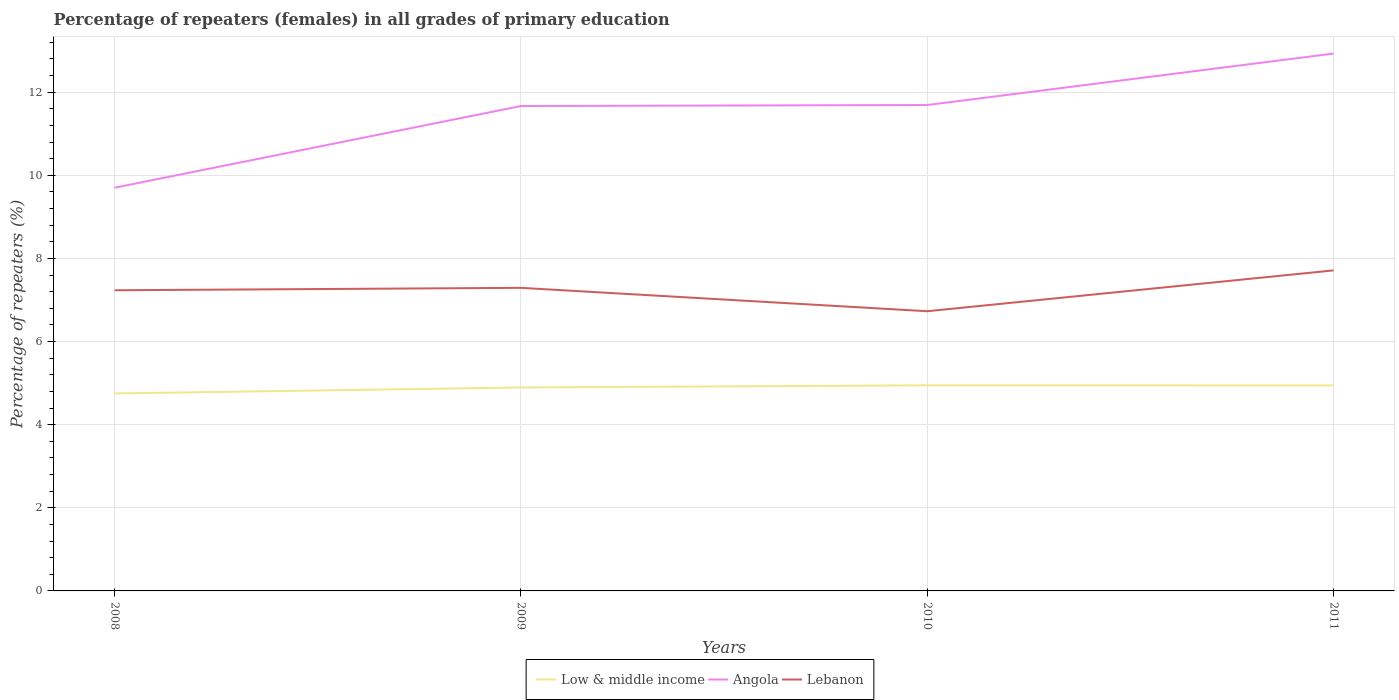Does the line corresponding to Low & middle income intersect with the line corresponding to Lebanon?
Ensure brevity in your answer.  No. Across all years, what is the maximum percentage of repeaters (females) in Angola?
Ensure brevity in your answer.  9.7. What is the total percentage of repeaters (females) in Low & middle income in the graph?
Offer a terse response. -0.2. What is the difference between the highest and the second highest percentage of repeaters (females) in Lebanon?
Your response must be concise. 0.98. Is the percentage of repeaters (females) in Low & middle income strictly greater than the percentage of repeaters (females) in Angola over the years?
Offer a terse response. Yes. How many lines are there?
Ensure brevity in your answer.  3. Does the graph contain any zero values?
Offer a very short reply. No. Does the graph contain grids?
Give a very brief answer. Yes. Where does the legend appear in the graph?
Offer a terse response. Bottom center. What is the title of the graph?
Make the answer very short. Percentage of repeaters (females) in all grades of primary education. Does "Russian Federation" appear as one of the legend labels in the graph?
Give a very brief answer. No. What is the label or title of the X-axis?
Provide a short and direct response. Years. What is the label or title of the Y-axis?
Give a very brief answer. Percentage of repeaters (%). What is the Percentage of repeaters (%) of Low & middle income in 2008?
Give a very brief answer. 4.75. What is the Percentage of repeaters (%) in Angola in 2008?
Offer a terse response. 9.7. What is the Percentage of repeaters (%) in Lebanon in 2008?
Provide a succinct answer. 7.23. What is the Percentage of repeaters (%) in Low & middle income in 2009?
Make the answer very short. 4.89. What is the Percentage of repeaters (%) in Angola in 2009?
Give a very brief answer. 11.67. What is the Percentage of repeaters (%) of Lebanon in 2009?
Your answer should be very brief. 7.29. What is the Percentage of repeaters (%) in Low & middle income in 2010?
Offer a very short reply. 4.95. What is the Percentage of repeaters (%) of Angola in 2010?
Ensure brevity in your answer.  11.69. What is the Percentage of repeaters (%) in Lebanon in 2010?
Give a very brief answer. 6.73. What is the Percentage of repeaters (%) of Low & middle income in 2011?
Your answer should be very brief. 4.94. What is the Percentage of repeaters (%) of Angola in 2011?
Give a very brief answer. 12.93. What is the Percentage of repeaters (%) in Lebanon in 2011?
Ensure brevity in your answer.  7.71. Across all years, what is the maximum Percentage of repeaters (%) of Low & middle income?
Your response must be concise. 4.95. Across all years, what is the maximum Percentage of repeaters (%) of Angola?
Your answer should be compact. 12.93. Across all years, what is the maximum Percentage of repeaters (%) of Lebanon?
Your answer should be compact. 7.71. Across all years, what is the minimum Percentage of repeaters (%) of Low & middle income?
Give a very brief answer. 4.75. Across all years, what is the minimum Percentage of repeaters (%) in Angola?
Offer a very short reply. 9.7. Across all years, what is the minimum Percentage of repeaters (%) of Lebanon?
Make the answer very short. 6.73. What is the total Percentage of repeaters (%) of Low & middle income in the graph?
Provide a short and direct response. 19.54. What is the total Percentage of repeaters (%) of Angola in the graph?
Ensure brevity in your answer.  45.99. What is the total Percentage of repeaters (%) of Lebanon in the graph?
Your answer should be compact. 28.97. What is the difference between the Percentage of repeaters (%) of Low & middle income in 2008 and that in 2009?
Your answer should be compact. -0.14. What is the difference between the Percentage of repeaters (%) in Angola in 2008 and that in 2009?
Provide a succinct answer. -1.97. What is the difference between the Percentage of repeaters (%) in Lebanon in 2008 and that in 2009?
Your answer should be compact. -0.06. What is the difference between the Percentage of repeaters (%) of Low & middle income in 2008 and that in 2010?
Your response must be concise. -0.2. What is the difference between the Percentage of repeaters (%) of Angola in 2008 and that in 2010?
Your answer should be compact. -1.99. What is the difference between the Percentage of repeaters (%) of Lebanon in 2008 and that in 2010?
Your answer should be very brief. 0.5. What is the difference between the Percentage of repeaters (%) in Low & middle income in 2008 and that in 2011?
Offer a terse response. -0.19. What is the difference between the Percentage of repeaters (%) in Angola in 2008 and that in 2011?
Offer a very short reply. -3.23. What is the difference between the Percentage of repeaters (%) of Lebanon in 2008 and that in 2011?
Offer a terse response. -0.48. What is the difference between the Percentage of repeaters (%) in Low & middle income in 2009 and that in 2010?
Ensure brevity in your answer.  -0.05. What is the difference between the Percentage of repeaters (%) in Angola in 2009 and that in 2010?
Provide a short and direct response. -0.02. What is the difference between the Percentage of repeaters (%) in Lebanon in 2009 and that in 2010?
Your response must be concise. 0.56. What is the difference between the Percentage of repeaters (%) of Angola in 2009 and that in 2011?
Provide a succinct answer. -1.26. What is the difference between the Percentage of repeaters (%) in Lebanon in 2009 and that in 2011?
Make the answer very short. -0.42. What is the difference between the Percentage of repeaters (%) of Low & middle income in 2010 and that in 2011?
Give a very brief answer. 0. What is the difference between the Percentage of repeaters (%) of Angola in 2010 and that in 2011?
Ensure brevity in your answer.  -1.24. What is the difference between the Percentage of repeaters (%) in Lebanon in 2010 and that in 2011?
Give a very brief answer. -0.98. What is the difference between the Percentage of repeaters (%) of Low & middle income in 2008 and the Percentage of repeaters (%) of Angola in 2009?
Keep it short and to the point. -6.92. What is the difference between the Percentage of repeaters (%) in Low & middle income in 2008 and the Percentage of repeaters (%) in Lebanon in 2009?
Offer a very short reply. -2.54. What is the difference between the Percentage of repeaters (%) in Angola in 2008 and the Percentage of repeaters (%) in Lebanon in 2009?
Offer a very short reply. 2.41. What is the difference between the Percentage of repeaters (%) in Low & middle income in 2008 and the Percentage of repeaters (%) in Angola in 2010?
Make the answer very short. -6.94. What is the difference between the Percentage of repeaters (%) in Low & middle income in 2008 and the Percentage of repeaters (%) in Lebanon in 2010?
Ensure brevity in your answer.  -1.98. What is the difference between the Percentage of repeaters (%) of Angola in 2008 and the Percentage of repeaters (%) of Lebanon in 2010?
Offer a very short reply. 2.97. What is the difference between the Percentage of repeaters (%) of Low & middle income in 2008 and the Percentage of repeaters (%) of Angola in 2011?
Provide a short and direct response. -8.18. What is the difference between the Percentage of repeaters (%) in Low & middle income in 2008 and the Percentage of repeaters (%) in Lebanon in 2011?
Your response must be concise. -2.96. What is the difference between the Percentage of repeaters (%) of Angola in 2008 and the Percentage of repeaters (%) of Lebanon in 2011?
Keep it short and to the point. 1.99. What is the difference between the Percentage of repeaters (%) of Low & middle income in 2009 and the Percentage of repeaters (%) of Angola in 2010?
Ensure brevity in your answer.  -6.8. What is the difference between the Percentage of repeaters (%) in Low & middle income in 2009 and the Percentage of repeaters (%) in Lebanon in 2010?
Provide a succinct answer. -1.83. What is the difference between the Percentage of repeaters (%) in Angola in 2009 and the Percentage of repeaters (%) in Lebanon in 2010?
Offer a very short reply. 4.94. What is the difference between the Percentage of repeaters (%) of Low & middle income in 2009 and the Percentage of repeaters (%) of Angola in 2011?
Make the answer very short. -8.03. What is the difference between the Percentage of repeaters (%) in Low & middle income in 2009 and the Percentage of repeaters (%) in Lebanon in 2011?
Provide a short and direct response. -2.82. What is the difference between the Percentage of repeaters (%) in Angola in 2009 and the Percentage of repeaters (%) in Lebanon in 2011?
Your response must be concise. 3.95. What is the difference between the Percentage of repeaters (%) of Low & middle income in 2010 and the Percentage of repeaters (%) of Angola in 2011?
Give a very brief answer. -7.98. What is the difference between the Percentage of repeaters (%) in Low & middle income in 2010 and the Percentage of repeaters (%) in Lebanon in 2011?
Provide a short and direct response. -2.77. What is the difference between the Percentage of repeaters (%) of Angola in 2010 and the Percentage of repeaters (%) of Lebanon in 2011?
Ensure brevity in your answer.  3.98. What is the average Percentage of repeaters (%) in Low & middle income per year?
Offer a terse response. 4.88. What is the average Percentage of repeaters (%) of Angola per year?
Make the answer very short. 11.5. What is the average Percentage of repeaters (%) in Lebanon per year?
Give a very brief answer. 7.24. In the year 2008, what is the difference between the Percentage of repeaters (%) in Low & middle income and Percentage of repeaters (%) in Angola?
Ensure brevity in your answer.  -4.95. In the year 2008, what is the difference between the Percentage of repeaters (%) in Low & middle income and Percentage of repeaters (%) in Lebanon?
Make the answer very short. -2.48. In the year 2008, what is the difference between the Percentage of repeaters (%) in Angola and Percentage of repeaters (%) in Lebanon?
Ensure brevity in your answer.  2.47. In the year 2009, what is the difference between the Percentage of repeaters (%) of Low & middle income and Percentage of repeaters (%) of Angola?
Make the answer very short. -6.77. In the year 2009, what is the difference between the Percentage of repeaters (%) in Low & middle income and Percentage of repeaters (%) in Lebanon?
Provide a succinct answer. -2.4. In the year 2009, what is the difference between the Percentage of repeaters (%) of Angola and Percentage of repeaters (%) of Lebanon?
Provide a succinct answer. 4.37. In the year 2010, what is the difference between the Percentage of repeaters (%) in Low & middle income and Percentage of repeaters (%) in Angola?
Give a very brief answer. -6.74. In the year 2010, what is the difference between the Percentage of repeaters (%) of Low & middle income and Percentage of repeaters (%) of Lebanon?
Provide a short and direct response. -1.78. In the year 2010, what is the difference between the Percentage of repeaters (%) of Angola and Percentage of repeaters (%) of Lebanon?
Keep it short and to the point. 4.96. In the year 2011, what is the difference between the Percentage of repeaters (%) of Low & middle income and Percentage of repeaters (%) of Angola?
Provide a succinct answer. -7.98. In the year 2011, what is the difference between the Percentage of repeaters (%) in Low & middle income and Percentage of repeaters (%) in Lebanon?
Keep it short and to the point. -2.77. In the year 2011, what is the difference between the Percentage of repeaters (%) in Angola and Percentage of repeaters (%) in Lebanon?
Make the answer very short. 5.22. What is the ratio of the Percentage of repeaters (%) in Low & middle income in 2008 to that in 2009?
Keep it short and to the point. 0.97. What is the ratio of the Percentage of repeaters (%) of Angola in 2008 to that in 2009?
Keep it short and to the point. 0.83. What is the ratio of the Percentage of repeaters (%) of Low & middle income in 2008 to that in 2010?
Provide a succinct answer. 0.96. What is the ratio of the Percentage of repeaters (%) in Angola in 2008 to that in 2010?
Your answer should be very brief. 0.83. What is the ratio of the Percentage of repeaters (%) of Lebanon in 2008 to that in 2010?
Provide a short and direct response. 1.07. What is the ratio of the Percentage of repeaters (%) of Low & middle income in 2008 to that in 2011?
Offer a terse response. 0.96. What is the ratio of the Percentage of repeaters (%) of Angola in 2008 to that in 2011?
Make the answer very short. 0.75. What is the ratio of the Percentage of repeaters (%) of Lebanon in 2008 to that in 2011?
Provide a succinct answer. 0.94. What is the ratio of the Percentage of repeaters (%) in Low & middle income in 2009 to that in 2010?
Make the answer very short. 0.99. What is the ratio of the Percentage of repeaters (%) in Lebanon in 2009 to that in 2010?
Provide a short and direct response. 1.08. What is the ratio of the Percentage of repeaters (%) of Low & middle income in 2009 to that in 2011?
Make the answer very short. 0.99. What is the ratio of the Percentage of repeaters (%) of Angola in 2009 to that in 2011?
Your answer should be compact. 0.9. What is the ratio of the Percentage of repeaters (%) of Lebanon in 2009 to that in 2011?
Provide a succinct answer. 0.95. What is the ratio of the Percentage of repeaters (%) in Angola in 2010 to that in 2011?
Make the answer very short. 0.9. What is the ratio of the Percentage of repeaters (%) of Lebanon in 2010 to that in 2011?
Keep it short and to the point. 0.87. What is the difference between the highest and the second highest Percentage of repeaters (%) in Low & middle income?
Offer a terse response. 0. What is the difference between the highest and the second highest Percentage of repeaters (%) of Angola?
Your answer should be very brief. 1.24. What is the difference between the highest and the second highest Percentage of repeaters (%) in Lebanon?
Ensure brevity in your answer.  0.42. What is the difference between the highest and the lowest Percentage of repeaters (%) in Low & middle income?
Provide a succinct answer. 0.2. What is the difference between the highest and the lowest Percentage of repeaters (%) of Angola?
Offer a terse response. 3.23. What is the difference between the highest and the lowest Percentage of repeaters (%) of Lebanon?
Offer a terse response. 0.98. 